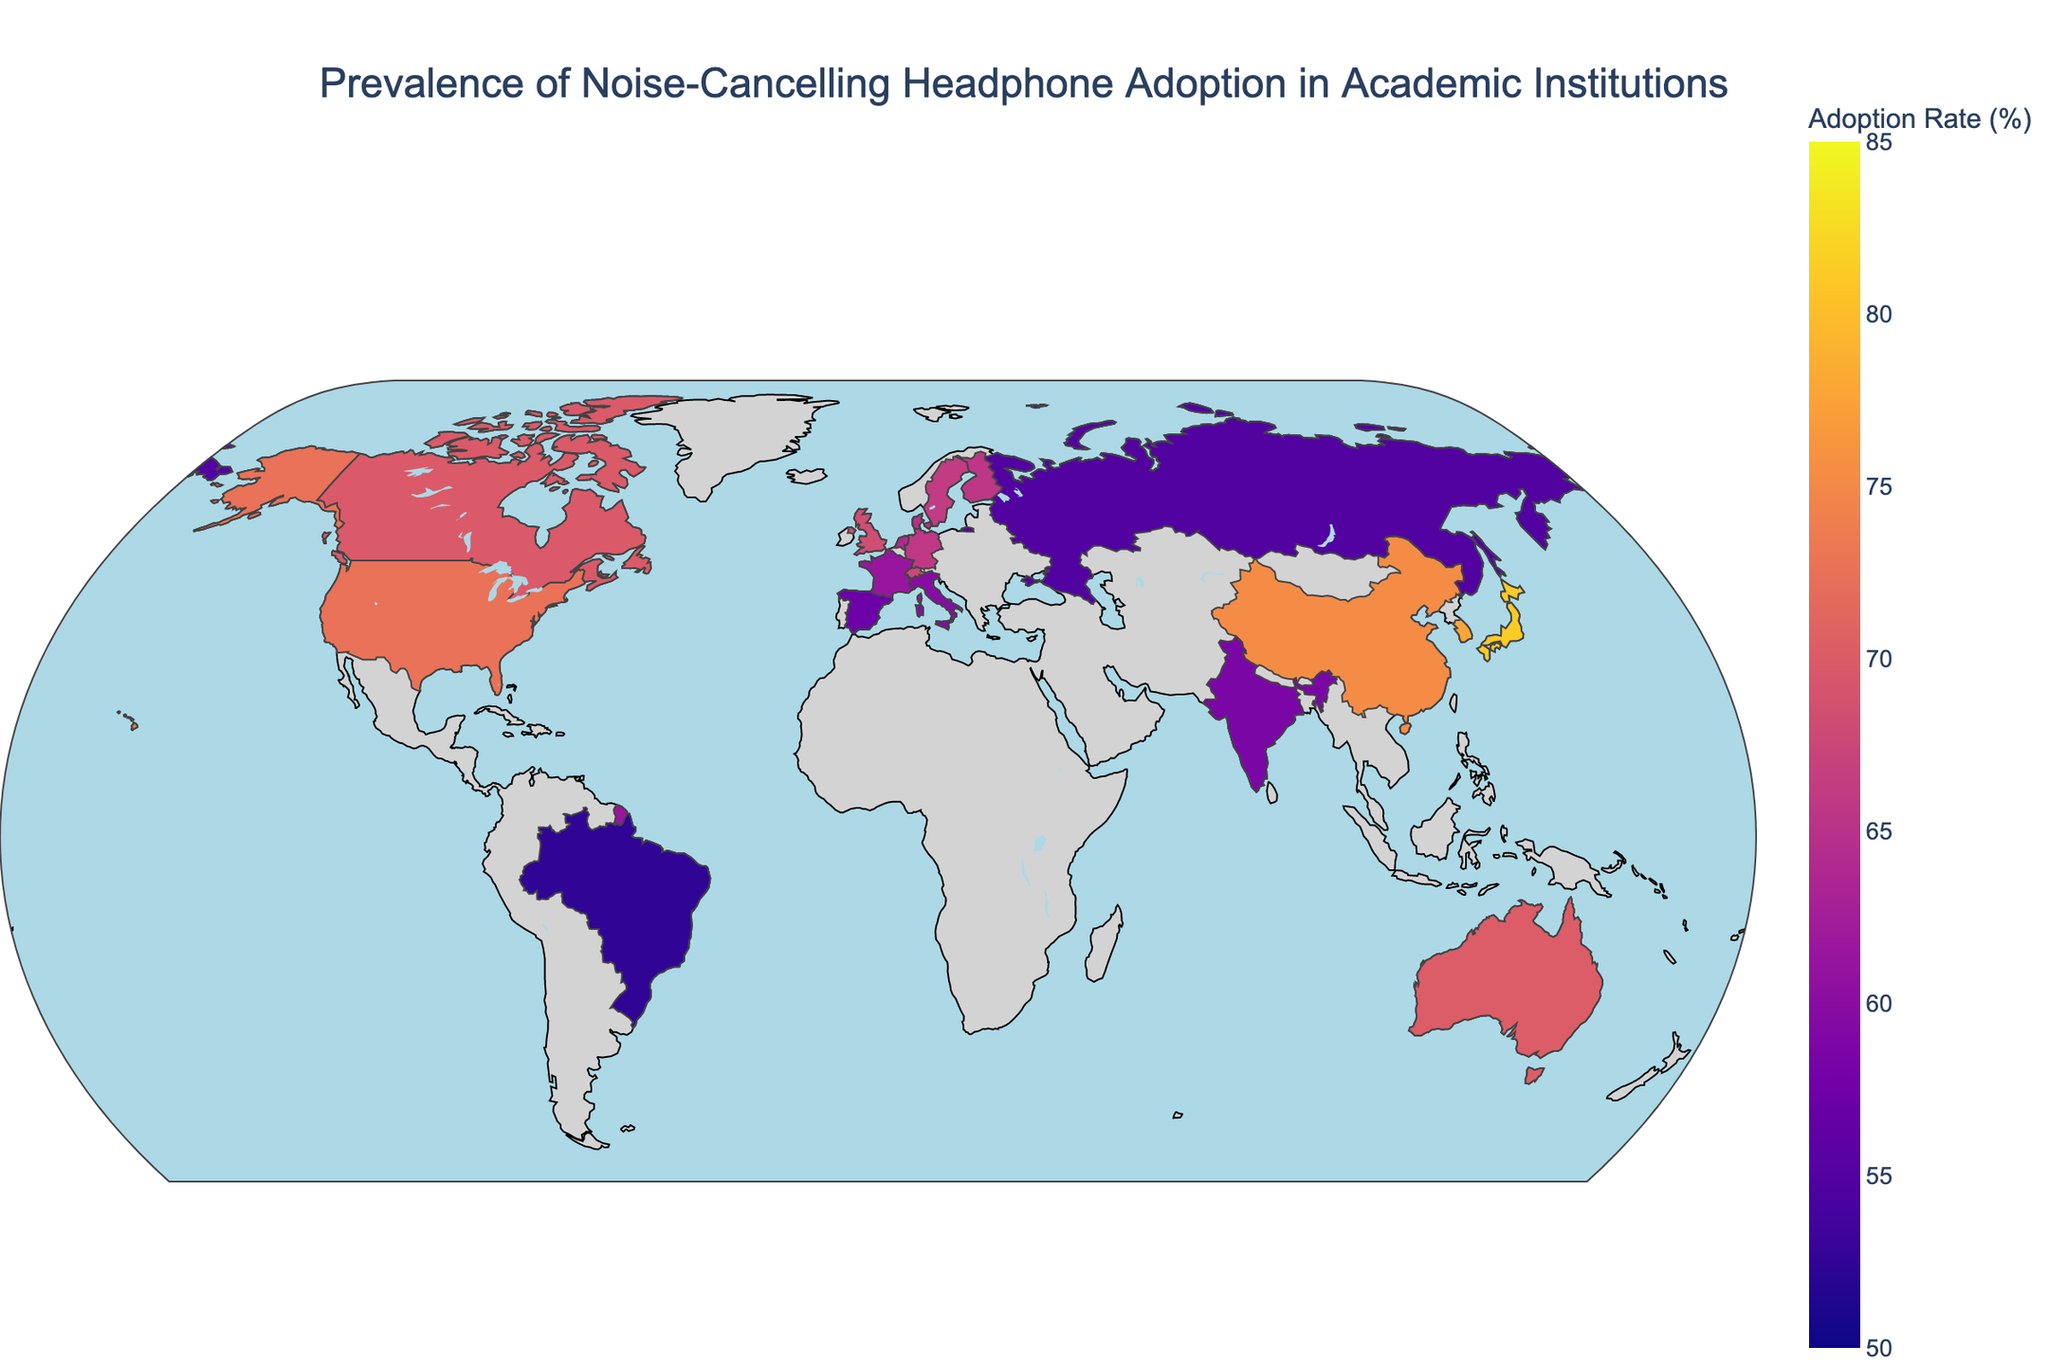Which country has the highest adoption rate of noise-cancelling headphones in academic institutions? Scan the color intensity on the map, the darkest color represents the highest adoption rate. Japan stands out as the darkest region.
Answer: Japan What is the adoption rate of noise-cancelling headphones in Brazil? Locate Brazil on the map and observe the color. Alternatively, hover over Brazil to see the rate. The map shows Brazil with a lighter color indicating an adoption rate.
Answer: 52.4% Which countries have adoption rates higher than 75%? Identify regions with the darkest shades, usually indicating rates above 75%. Cross-check countries on the color scale. Japan, Singapore, South Korea, and China all exceed 75%.
Answer: Japan, Singapore, South Korea, China What is the difference in adoption rates between the United States and India? Check the adoption rates from the legend or hover function. Subtract India's rate from the United States’ rate. The United States is 72.5%, and India is 58.6%, so 72.5 - 58.6 = 13.9%.
Answer: 13.9% Compare the adoption rates of noise-cancelling headphones between Europe and Asia. Which continent has higher average rates? Identify the European (e.g., Germany, France) and Asian countries (e.g., Japan, China), sum their rates, and compute averages. Europe’s major countries (United Kingdom, Germany, France, etc.) have slightly lower rates on average compared to Asia (Japan, South Korea, China).
Answer: Asia What is the median adoption rate among the listed countries? List the adoption rates in ascending order and determine the middle value. The ordered rates are: 52.4, 54.9, 57.2, 58.6, 59.7, 61.4, 63.9, 64.8, 65.6, 65.7, 66.2, 67.5, 68.3, 69.8, 70.1, 72.5, 75.3, 77.8, 79.5, 81.2. The median is the average of the 10th and 11th values: (65.7 + 66.2)/2 = 65.95.
Answer: 65.95 How does the adoption rate in Australia compare to that in Canada? Locate both countries on the map, observe their color shades, or use hover to get specific values. Australia’s adoption rate is slightly higher than Canada’s (70.1% vs. 69.8%).
Answer: Australia is slightly higher What trends can be observed concerning the adoption rates in Scandinavian countries (Sweden, Denmark, Finland)? Look at these countries in the region and assess their color shades. All three Scandinavian countries have adoption rates close to each other, ranging from 64.8% to 66.2%.
Answer: Similar high adoption rates Which European country has the lowest adoption rate of noise-cancelling headphones? Focus on European regions and identify the country with the lightest shade. Spain, with a rate of 57.2%, shows the lowest rate among European countries.
Answer: Spain What’s the average adoption rate of noise-cancelling headphones in the listed countries? Sum up all the adoption rates and divide by the number of countries (20). Total sum is 1283.7. So, the average rate is 1283.7/20 = 64.185.
Answer: 64.185 